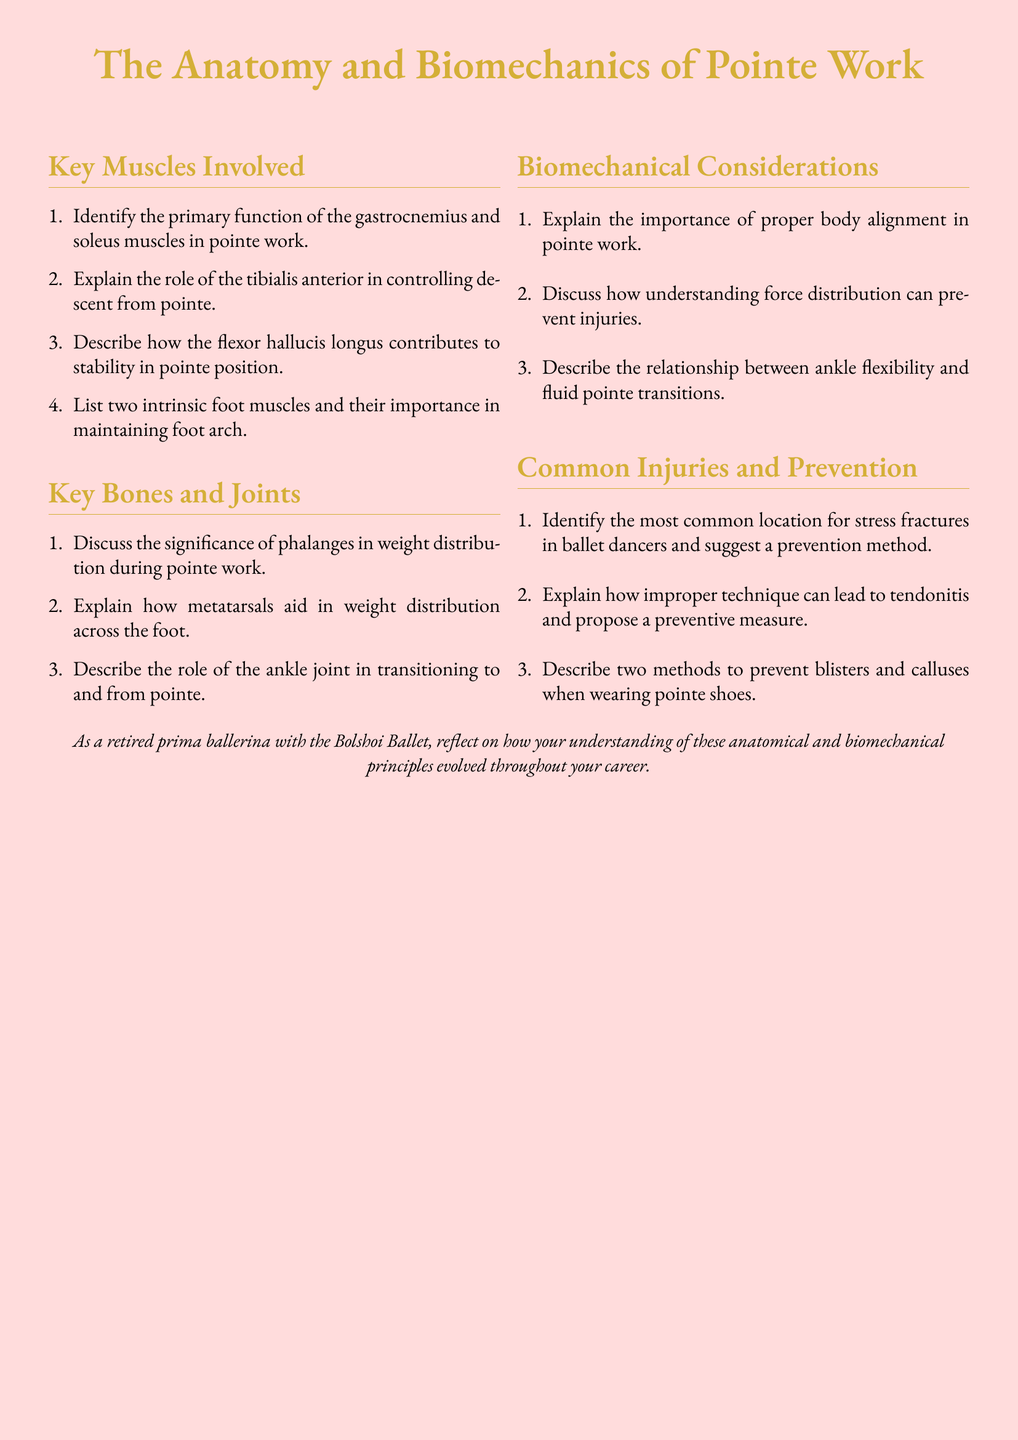what is the primary function of the gastrocnemius in pointe work? The document indicates the gastrocnemius is one of the key muscles involved and focuses on weight transfer and stabilization during pointe.
Answer: weight transfer and stabilization what role does the tibialis anterior serve in pointe work? The tibialis anterior's role is highlighted in the document as controlling the descent from pointe, which is critical for safe landings.
Answer: controlling descent from pointe name two intrinsic foot muscles mentioned in the document. The document lists intrinsic foot muscles as being important for maintaining foot arch, requiring identification of two such muscles.
Answer: not specified what is the significance of phalanges in weight distribution? The document describes the importance of phalanges, indicating their role in how weight is balanced during pointe work.
Answer: weight distribution how does improper technique lead to tendonitis? The document explains that improper technique can cause injuries like tendonitis, implying a need to improve technique to prevent issues.
Answer: improper technique what can contribute to blisters and calluses with pointe shoes? The document addresses methods to prevent blisters and calluses, with a focus on appropriate shoe fitting and maintenance.
Answer: shoe fitting and maintenance what is the relationship between ankle flexibility and pointe transitions? The document suggests that ankle flexibility is a key factor for smooth transitions to and from pointe.
Answer: smooth transitions identify a common location for stress fractures in ballet dancers. The document discusses injuries, indicating that stress fractures primarily occur in a likely location, often the metatarsals or foot area.
Answer: foot area what is emphasized in the document as vital for injury prevention? The overall themes of the document stress proper technique and knowledge of biomechanics to reduce injury risk in dancers.
Answer: proper technique and biomechanics 